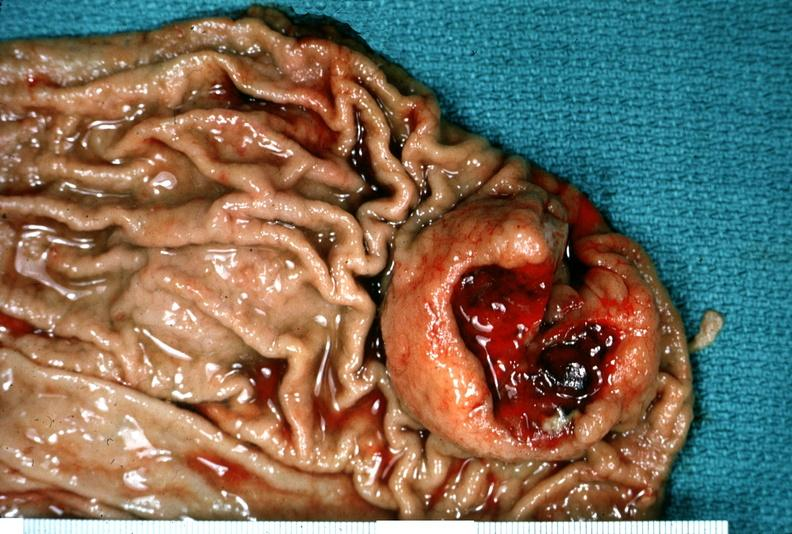does slide show stomach, leiomyoma with ulcerated mucosal surface?
Answer the question using a single word or phrase. No 